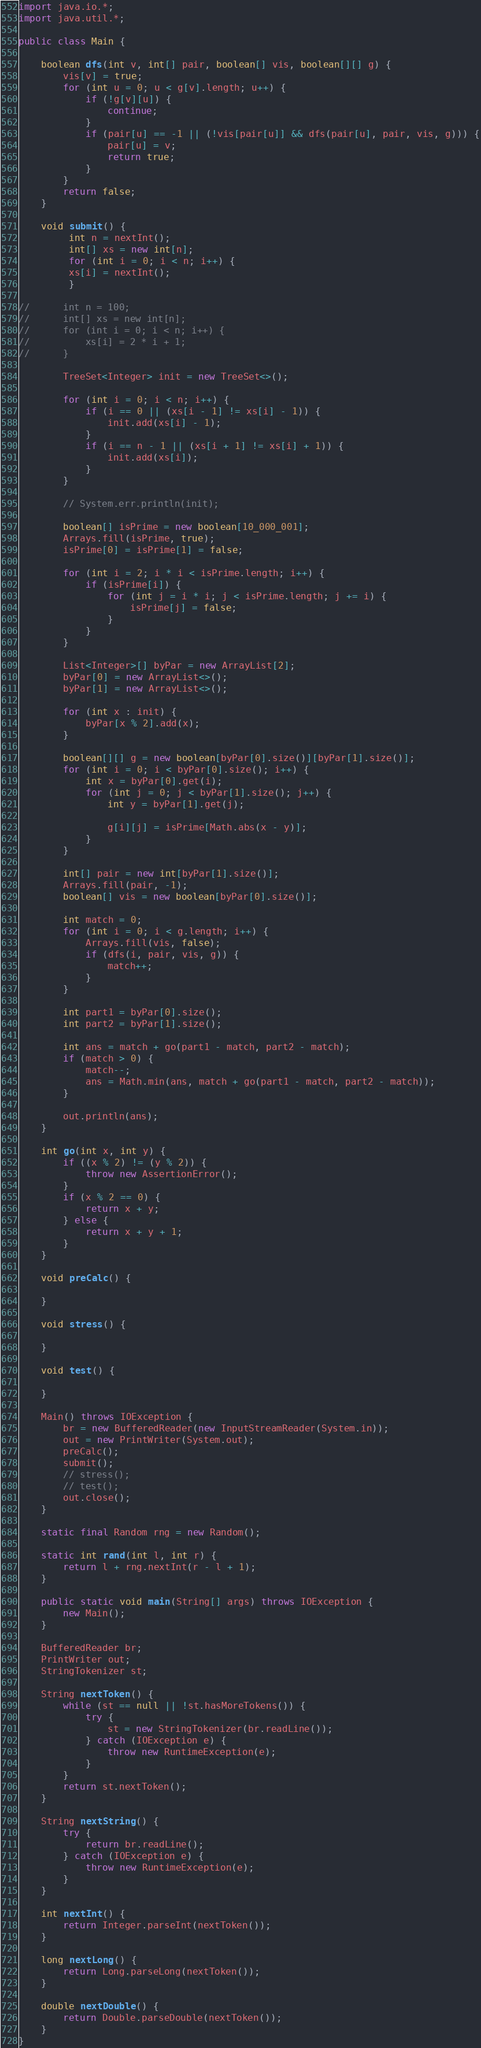<code> <loc_0><loc_0><loc_500><loc_500><_Java_>import java.io.*;
import java.util.*;

public class Main {

	boolean dfs(int v, int[] pair, boolean[] vis, boolean[][] g) {
		vis[v] = true;
		for (int u = 0; u < g[v].length; u++) {
			if (!g[v][u]) {
				continue;
			}
			if (pair[u] == -1 || (!vis[pair[u]] && dfs(pair[u], pair, vis, g))) {
				pair[u] = v;
				return true;
			}
		}
		return false;
	}

	void submit() {
		 int n = nextInt();
		 int[] xs = new int[n];
		 for (int i = 0; i < n; i++) {
		 xs[i] = nextInt();
		 }

//		int n = 100;
//		int[] xs = new int[n];
//		for (int i = 0; i < n; i++) {
//			xs[i] = 2 * i + 1;
//		}

		TreeSet<Integer> init = new TreeSet<>();

		for (int i = 0; i < n; i++) {
			if (i == 0 || (xs[i - 1] != xs[i] - 1)) {
				init.add(xs[i] - 1);
			}
			if (i == n - 1 || (xs[i + 1] != xs[i] + 1)) {
				init.add(xs[i]);
			}
		}

		// System.err.println(init);

		boolean[] isPrime = new boolean[10_000_001];
		Arrays.fill(isPrime, true);
		isPrime[0] = isPrime[1] = false;

		for (int i = 2; i * i < isPrime.length; i++) {
			if (isPrime[i]) {
				for (int j = i * i; j < isPrime.length; j += i) {
					isPrime[j] = false;
				}
			}
		}

		List<Integer>[] byPar = new ArrayList[2];
		byPar[0] = new ArrayList<>();
		byPar[1] = new ArrayList<>();

		for (int x : init) {
			byPar[x % 2].add(x);
		}

		boolean[][] g = new boolean[byPar[0].size()][byPar[1].size()];
		for (int i = 0; i < byPar[0].size(); i++) {
			int x = byPar[0].get(i);
			for (int j = 0; j < byPar[1].size(); j++) {
				int y = byPar[1].get(j);

				g[i][j] = isPrime[Math.abs(x - y)];
			}
		}

		int[] pair = new int[byPar[1].size()];
		Arrays.fill(pair, -1);
		boolean[] vis = new boolean[byPar[0].size()];

		int match = 0;
		for (int i = 0; i < g.length; i++) {
			Arrays.fill(vis, false);
			if (dfs(i, pair, vis, g)) {
				match++;
			}
		}

		int part1 = byPar[0].size();
		int part2 = byPar[1].size();

		int ans = match + go(part1 - match, part2 - match);
		if (match > 0) {
			match--;
			ans = Math.min(ans, match + go(part1 - match, part2 - match));
		}

		out.println(ans);
	}

	int go(int x, int y) {
		if ((x % 2) != (y % 2)) {
			throw new AssertionError();
		}
		if (x % 2 == 0) {
			return x + y;
		} else {
			return x + y + 1;
		}
	}

	void preCalc() {

	}

	void stress() {

	}

	void test() {

	}

	Main() throws IOException {
		br = new BufferedReader(new InputStreamReader(System.in));
		out = new PrintWriter(System.out);
		preCalc();
		submit();
		// stress();
		// test();
		out.close();
	}

	static final Random rng = new Random();

	static int rand(int l, int r) {
		return l + rng.nextInt(r - l + 1);
	}

	public static void main(String[] args) throws IOException {
		new Main();
	}

	BufferedReader br;
	PrintWriter out;
	StringTokenizer st;

	String nextToken() {
		while (st == null || !st.hasMoreTokens()) {
			try {
				st = new StringTokenizer(br.readLine());
			} catch (IOException e) {
				throw new RuntimeException(e);
			}
		}
		return st.nextToken();
	}

	String nextString() {
		try {
			return br.readLine();
		} catch (IOException e) {
			throw new RuntimeException(e);
		}
	}

	int nextInt() {
		return Integer.parseInt(nextToken());
	}

	long nextLong() {
		return Long.parseLong(nextToken());
	}

	double nextDouble() {
		return Double.parseDouble(nextToken());
	}
}
</code> 